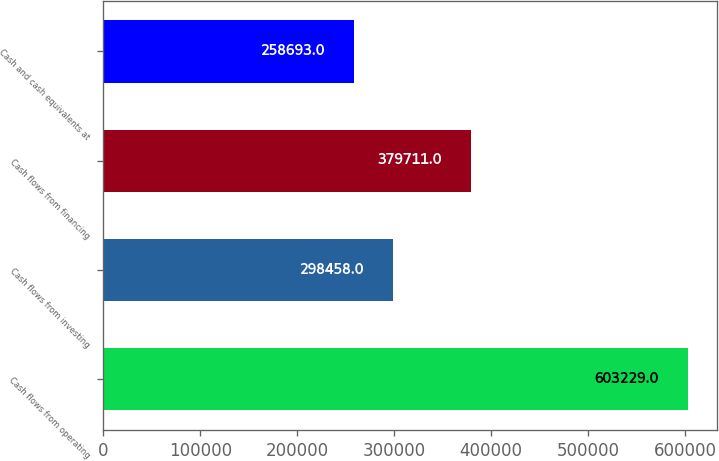<chart> <loc_0><loc_0><loc_500><loc_500><bar_chart><fcel>Cash flows from operating<fcel>Cash flows from investing<fcel>Cash flows from financing<fcel>Cash and cash equivalents at<nl><fcel>603229<fcel>298458<fcel>379711<fcel>258693<nl></chart> 